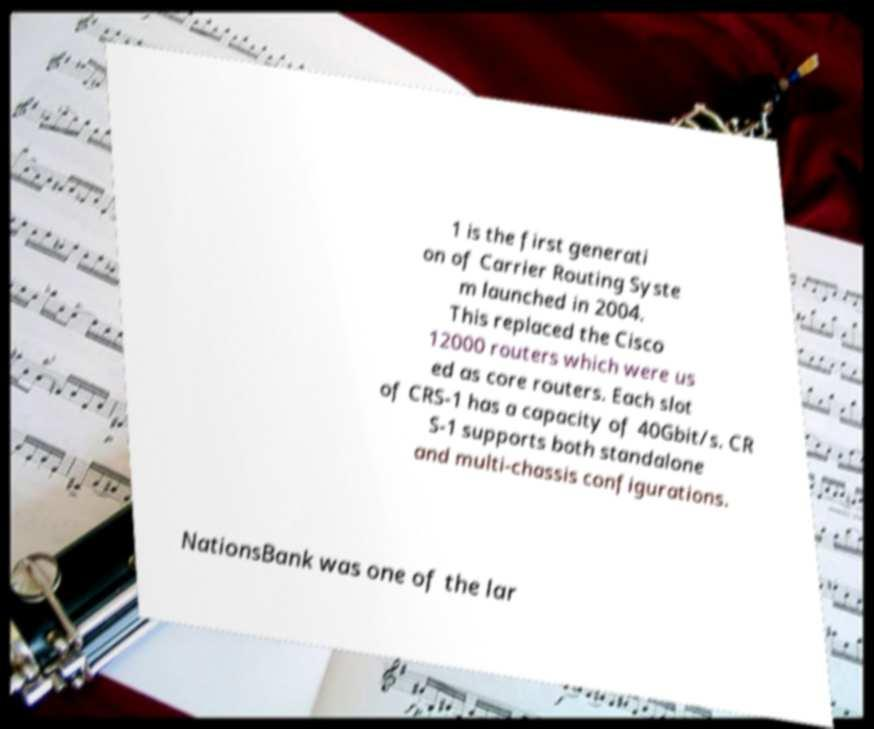Please read and relay the text visible in this image. What does it say? 1 is the first generati on of Carrier Routing Syste m launched in 2004. This replaced the Cisco 12000 routers which were us ed as core routers. Each slot of CRS-1 has a capacity of 40Gbit/s. CR S-1 supports both standalone and multi-chassis configurations. NationsBank was one of the lar 